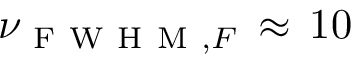Convert formula to latex. <formula><loc_0><loc_0><loc_500><loc_500>\nu _ { F W H M , F } \, \approx \, 1 0</formula> 